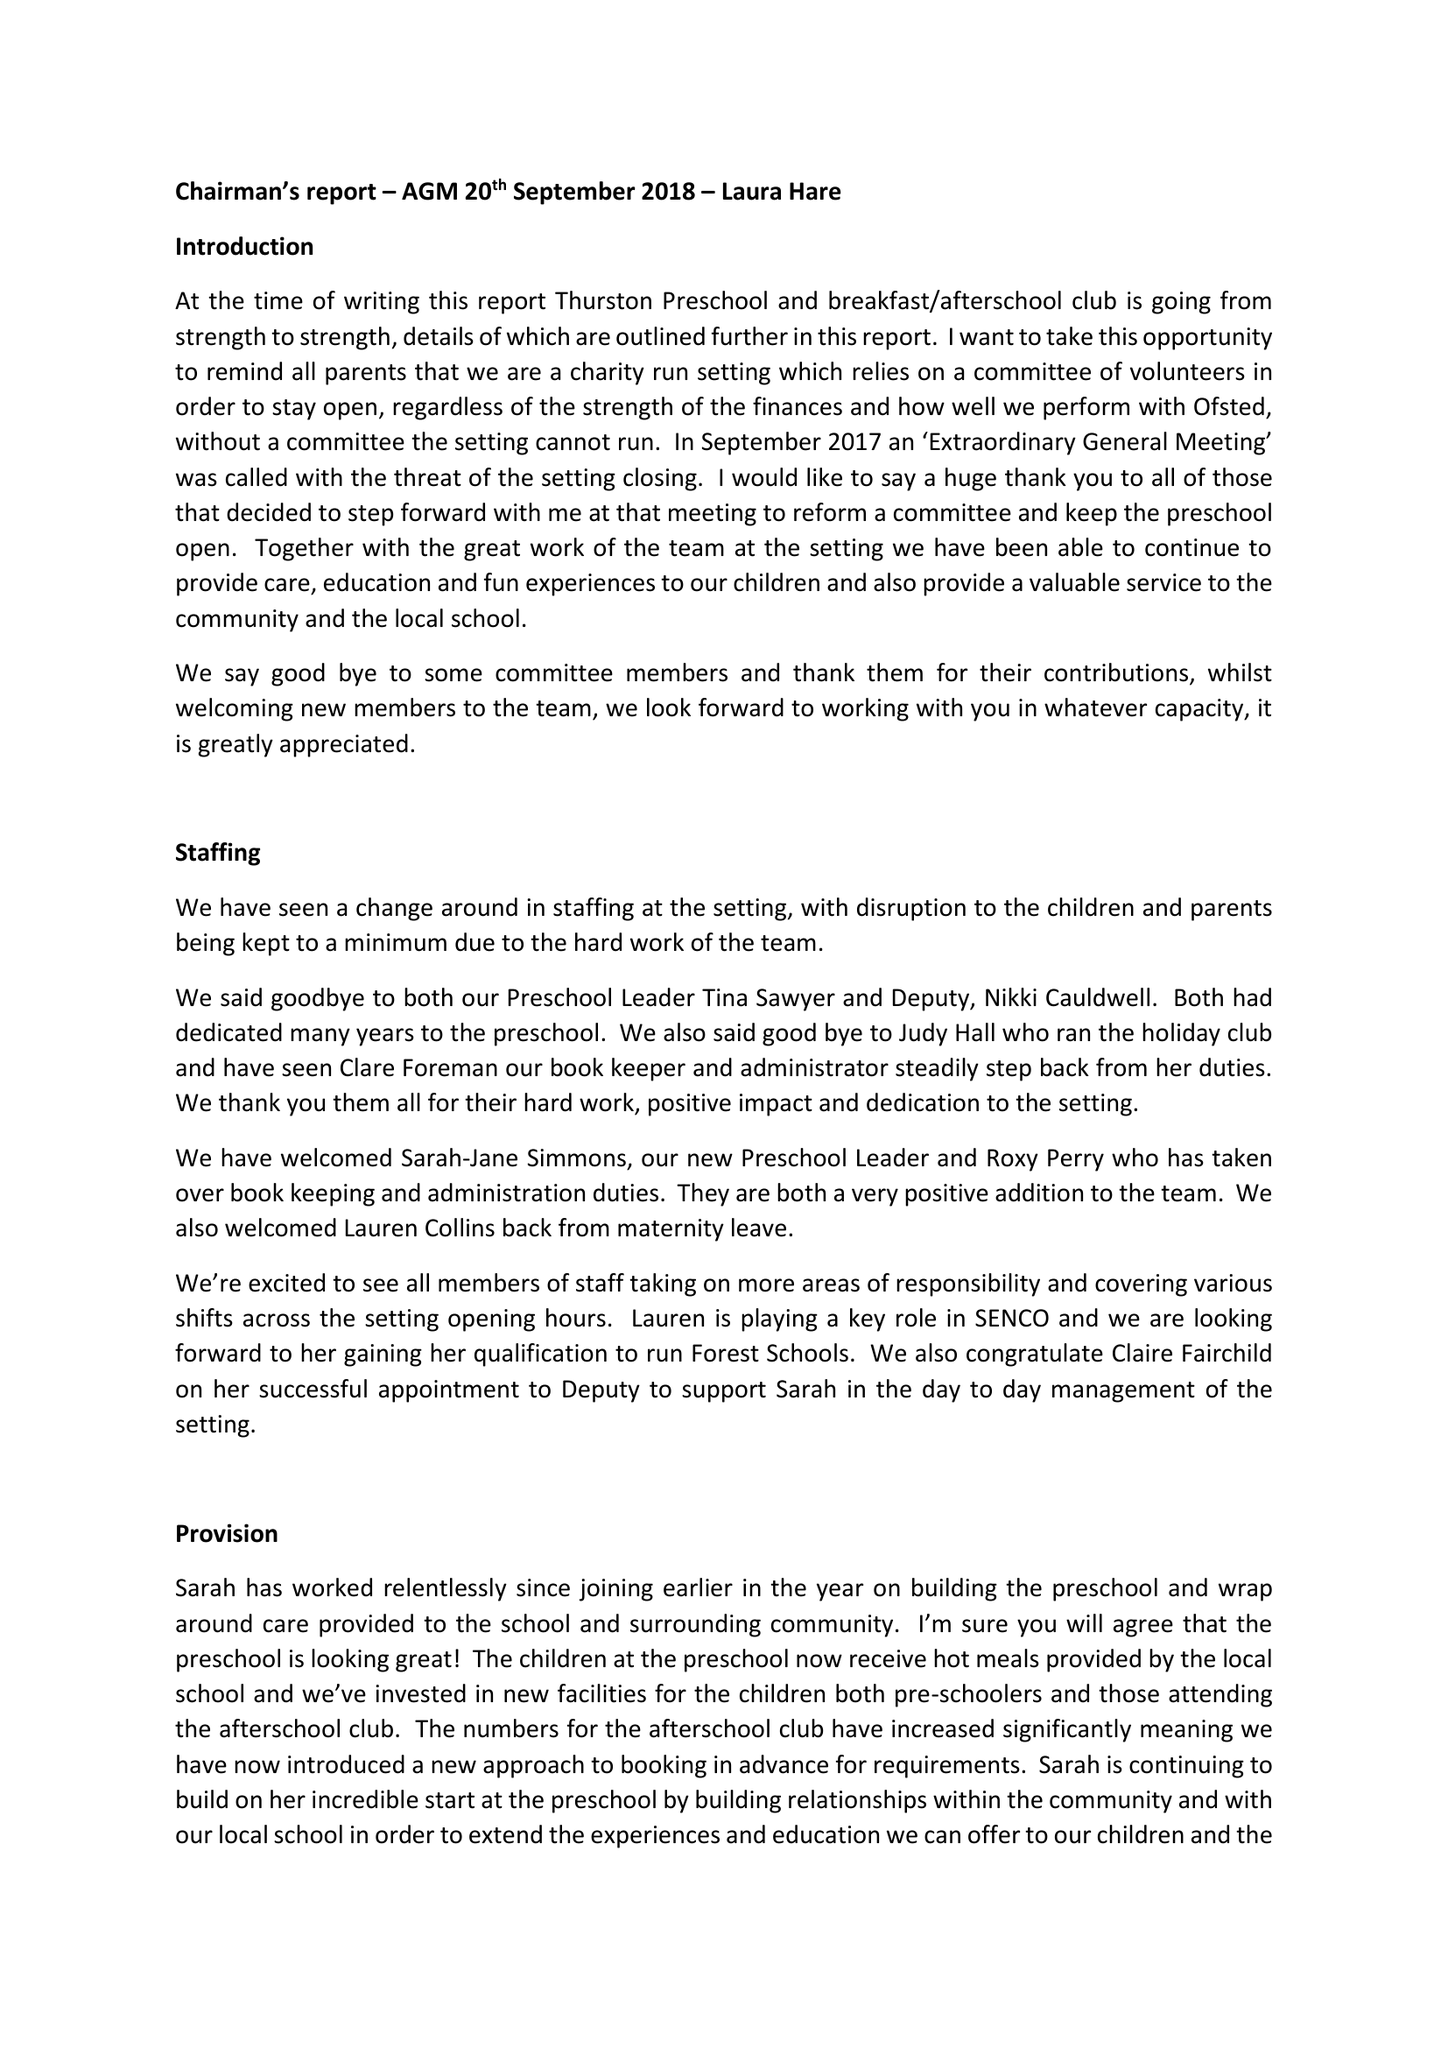What is the value for the income_annually_in_british_pounds?
Answer the question using a single word or phrase. 105163.00 